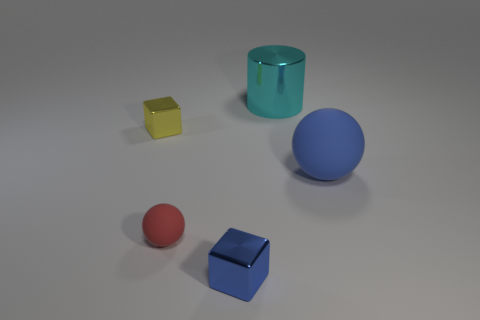Subtract all purple balls. Subtract all brown cylinders. How many balls are left? 2 Add 4 big cyan cylinders. How many objects exist? 9 Subtract all balls. How many objects are left? 3 Add 5 big balls. How many big balls exist? 6 Subtract 0 blue cylinders. How many objects are left? 5 Subtract all spheres. Subtract all green metal objects. How many objects are left? 3 Add 4 small blocks. How many small blocks are left? 6 